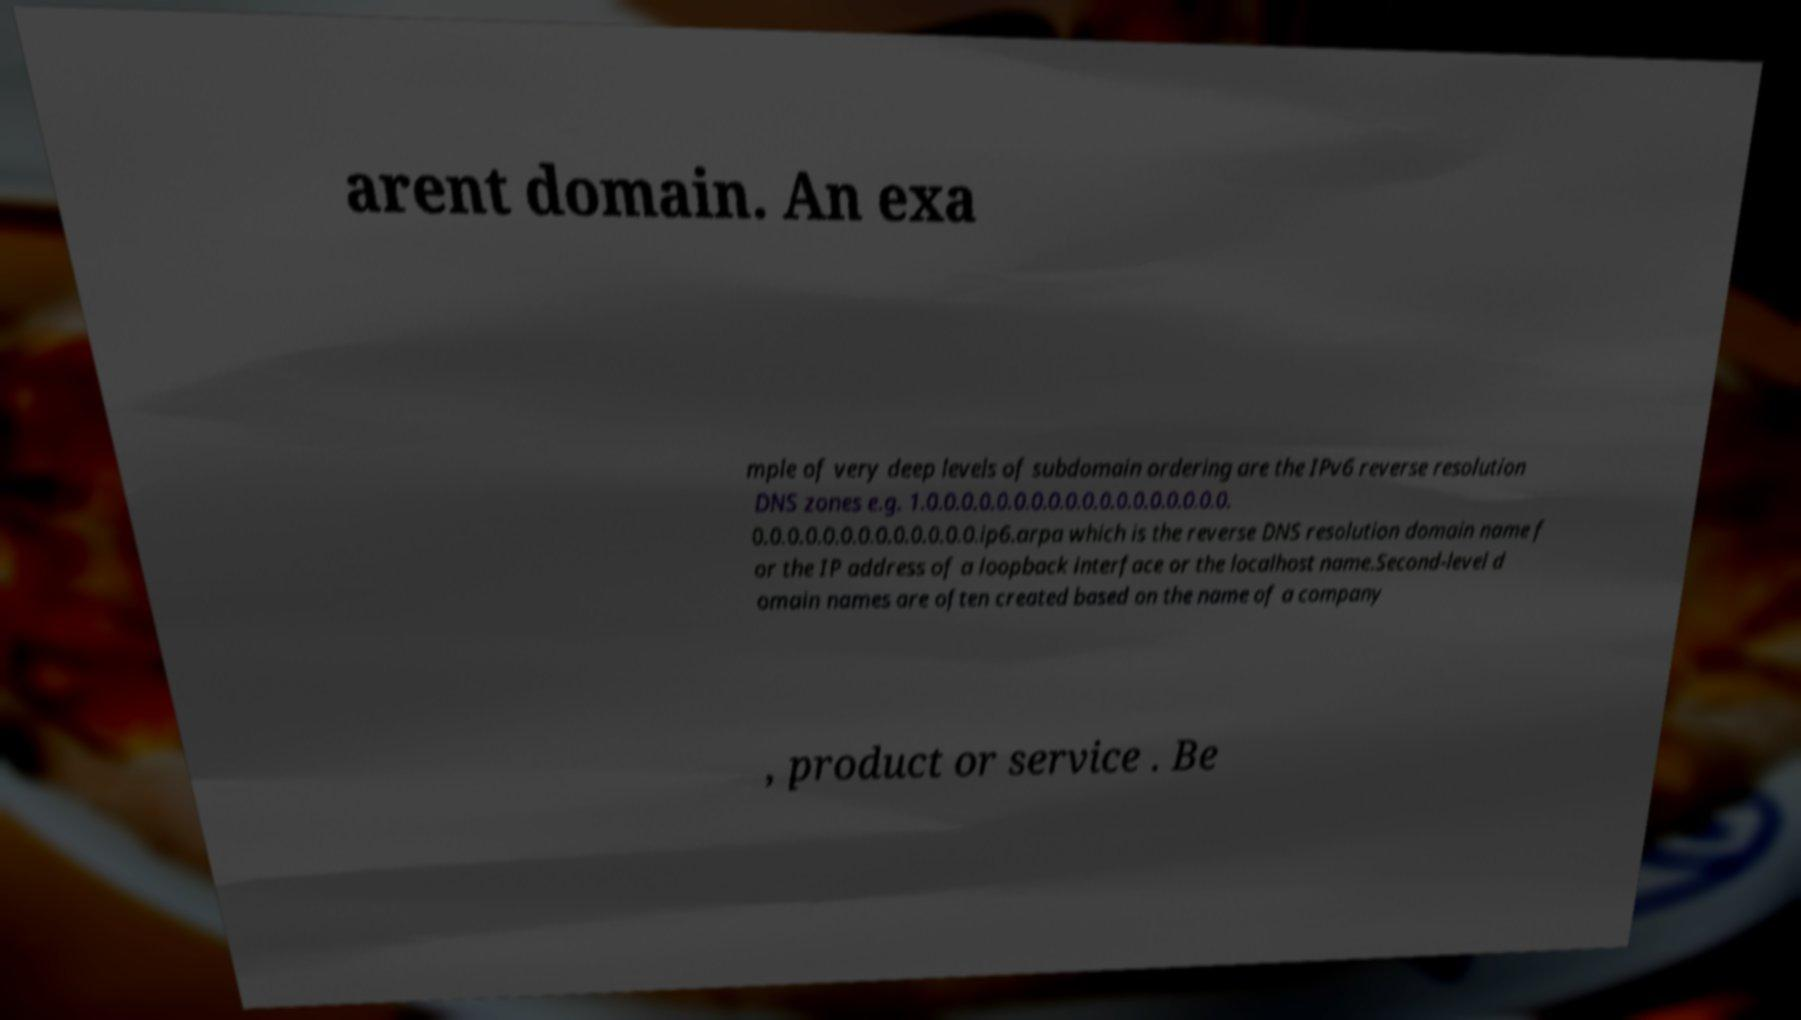I need the written content from this picture converted into text. Can you do that? arent domain. An exa mple of very deep levels of subdomain ordering are the IPv6 reverse resolution DNS zones e.g. 1.0.0.0.0.0.0.0.0.0.0.0.0.0.0.0.0.0.0. 0.0.0.0.0.0.0.0.0.0.0.0.0.ip6.arpa which is the reverse DNS resolution domain name f or the IP address of a loopback interface or the localhost name.Second-level d omain names are often created based on the name of a company , product or service . Be 